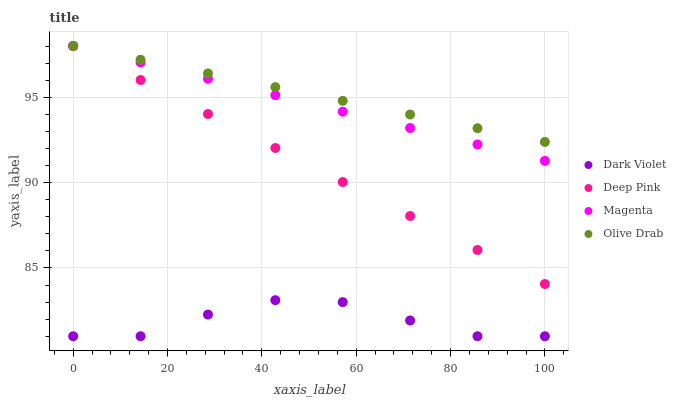Does Dark Violet have the minimum area under the curve?
Answer yes or no. Yes. Does Olive Drab have the maximum area under the curve?
Answer yes or no. Yes. Does Deep Pink have the minimum area under the curve?
Answer yes or no. No. Does Deep Pink have the maximum area under the curve?
Answer yes or no. No. Is Olive Drab the smoothest?
Answer yes or no. Yes. Is Dark Violet the roughest?
Answer yes or no. Yes. Is Deep Pink the smoothest?
Answer yes or no. No. Is Deep Pink the roughest?
Answer yes or no. No. Does Dark Violet have the lowest value?
Answer yes or no. Yes. Does Deep Pink have the lowest value?
Answer yes or no. No. Does Olive Drab have the highest value?
Answer yes or no. Yes. Does Dark Violet have the highest value?
Answer yes or no. No. Is Dark Violet less than Deep Pink?
Answer yes or no. Yes. Is Olive Drab greater than Dark Violet?
Answer yes or no. Yes. Does Deep Pink intersect Olive Drab?
Answer yes or no. Yes. Is Deep Pink less than Olive Drab?
Answer yes or no. No. Is Deep Pink greater than Olive Drab?
Answer yes or no. No. Does Dark Violet intersect Deep Pink?
Answer yes or no. No. 